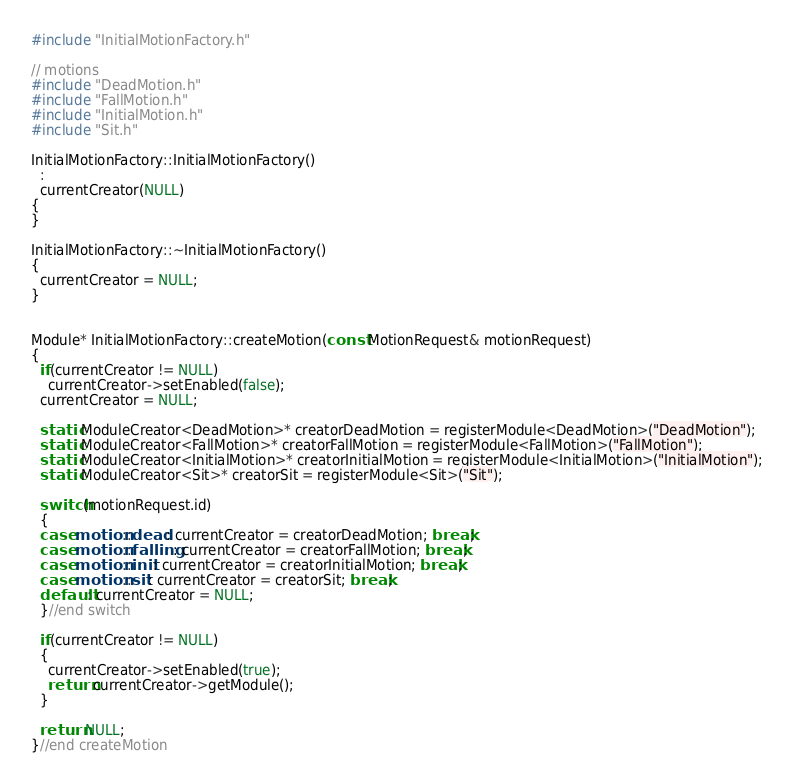Convert code to text. <code><loc_0><loc_0><loc_500><loc_500><_C++_>#include "InitialMotionFactory.h"

// motions
#include "DeadMotion.h"
#include "FallMotion.h"
#include "InitialMotion.h"
#include "Sit.h"

InitialMotionFactory::InitialMotionFactory()
  :
  currentCreator(NULL)
{
}

InitialMotionFactory::~InitialMotionFactory()
{
  currentCreator = NULL;
}


Module* InitialMotionFactory::createMotion(const MotionRequest& motionRequest)
{
  if(currentCreator != NULL)
    currentCreator->setEnabled(false);
  currentCreator = NULL;

  static ModuleCreator<DeadMotion>* creatorDeadMotion = registerModule<DeadMotion>("DeadMotion");
  static ModuleCreator<FallMotion>* creatorFallMotion = registerModule<FallMotion>("FallMotion");
  static ModuleCreator<InitialMotion>* creatorInitialMotion = registerModule<InitialMotion>("InitialMotion");
  static ModuleCreator<Sit>* creatorSit = registerModule<Sit>("Sit");
  
  switch(motionRequest.id)
  {
  case motion::dead: currentCreator = creatorDeadMotion; break;
  case motion::falling: currentCreator = creatorFallMotion; break;
  case motion::init: currentCreator = creatorInitialMotion; break;
  case motion::sit: currentCreator = creatorSit; break;
  default: currentCreator = NULL;
  }//end switch

  if(currentCreator != NULL)
  {
    currentCreator->setEnabled(true);
    return currentCreator->getModule();
  }

  return NULL;
}//end createMotion
</code> 